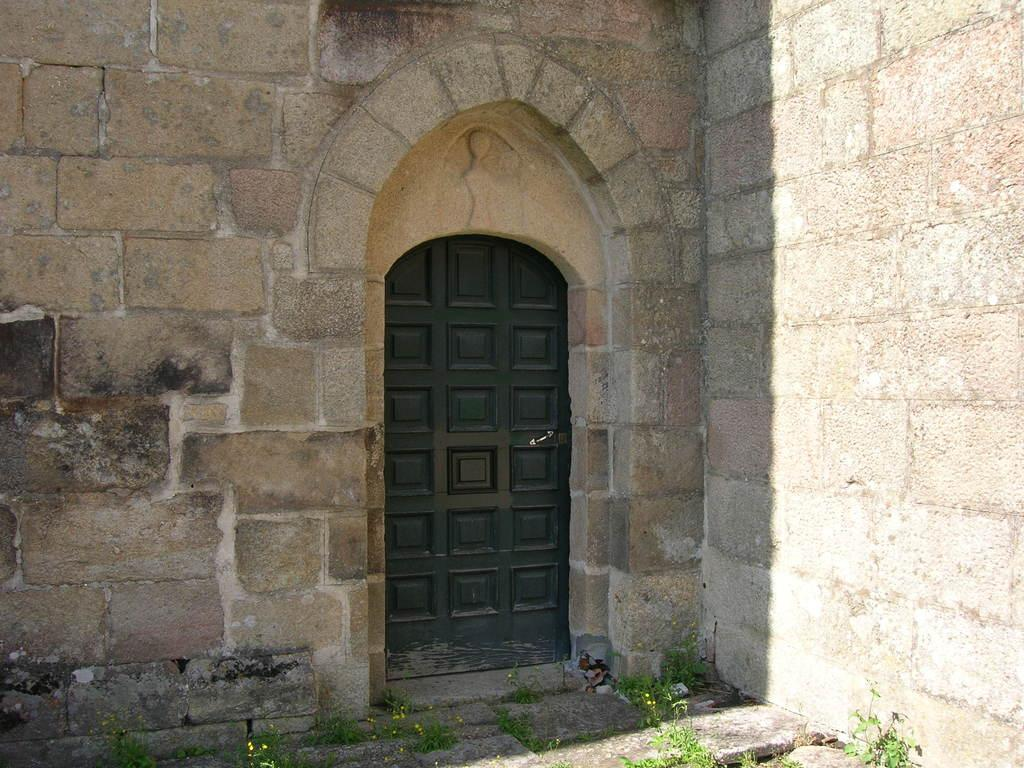What type of scene is depicted in the image? The image shows an outside view of a building. Can you describe a specific feature of the building? There is a door in the center of the image. What can be seen in the foreground of the image? There are plants in the foreground of the image. What month is it in the image? The image does not provide any information about the month or time of year. What thing is rolling down the street in the image? There is no object rolling down the street in the image. 